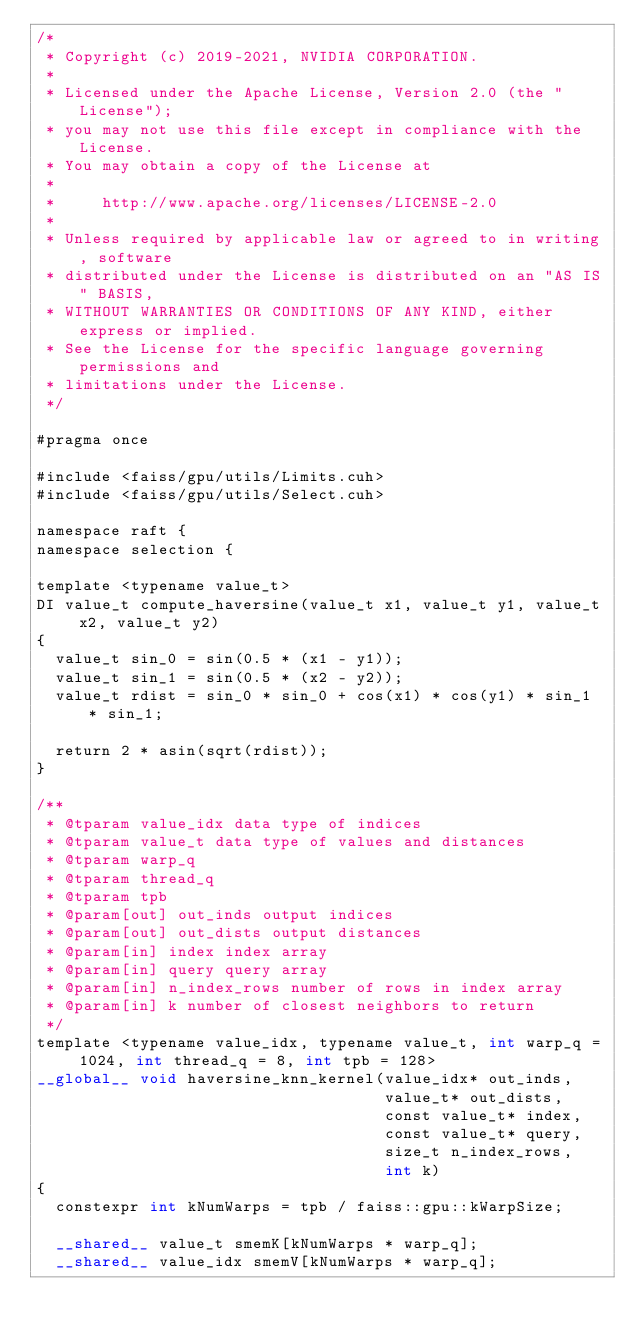Convert code to text. <code><loc_0><loc_0><loc_500><loc_500><_Cuda_>/*
 * Copyright (c) 2019-2021, NVIDIA CORPORATION.
 *
 * Licensed under the Apache License, Version 2.0 (the "License");
 * you may not use this file except in compliance with the License.
 * You may obtain a copy of the License at
 *
 *     http://www.apache.org/licenses/LICENSE-2.0
 *
 * Unless required by applicable law or agreed to in writing, software
 * distributed under the License is distributed on an "AS IS" BASIS,
 * WITHOUT WARRANTIES OR CONDITIONS OF ANY KIND, either express or implied.
 * See the License for the specific language governing permissions and
 * limitations under the License.
 */

#pragma once

#include <faiss/gpu/utils/Limits.cuh>
#include <faiss/gpu/utils/Select.cuh>

namespace raft {
namespace selection {

template <typename value_t>
DI value_t compute_haversine(value_t x1, value_t y1, value_t x2, value_t y2)
{
  value_t sin_0 = sin(0.5 * (x1 - y1));
  value_t sin_1 = sin(0.5 * (x2 - y2));
  value_t rdist = sin_0 * sin_0 + cos(x1) * cos(y1) * sin_1 * sin_1;

  return 2 * asin(sqrt(rdist));
}

/**
 * @tparam value_idx data type of indices
 * @tparam value_t data type of values and distances
 * @tparam warp_q
 * @tparam thread_q
 * @tparam tpb
 * @param[out] out_inds output indices
 * @param[out] out_dists output distances
 * @param[in] index index array
 * @param[in] query query array
 * @param[in] n_index_rows number of rows in index array
 * @param[in] k number of closest neighbors to return
 */
template <typename value_idx, typename value_t, int warp_q = 1024, int thread_q = 8, int tpb = 128>
__global__ void haversine_knn_kernel(value_idx* out_inds,
                                     value_t* out_dists,
                                     const value_t* index,
                                     const value_t* query,
                                     size_t n_index_rows,
                                     int k)
{
  constexpr int kNumWarps = tpb / faiss::gpu::kWarpSize;

  __shared__ value_t smemK[kNumWarps * warp_q];
  __shared__ value_idx smemV[kNumWarps * warp_q];
</code> 